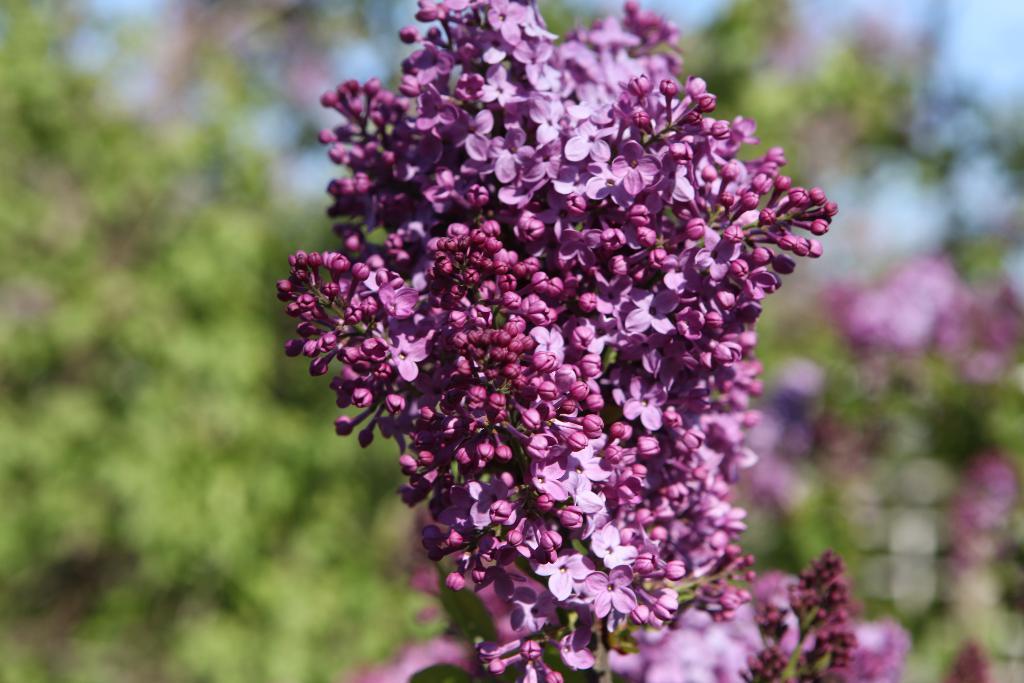Could you give a brief overview of what you see in this image? In this image we can see some flowers and in the background the image is blurred. 